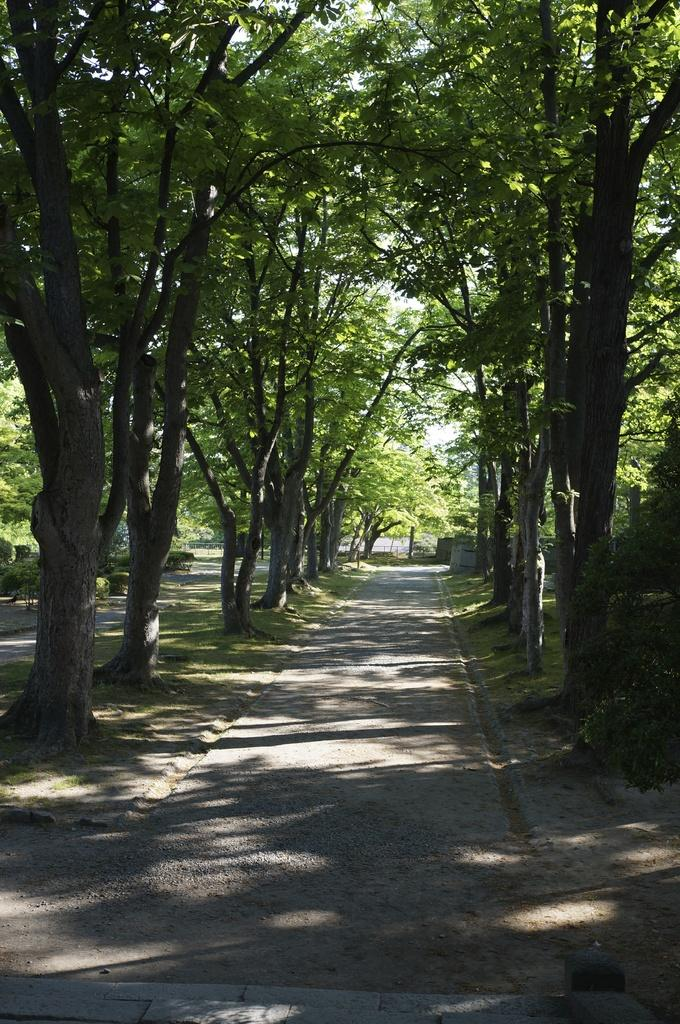What type of vegetation can be seen in the image? There are trees and plants visible in the image. What type of ground cover is present in the image? There is grass visible in the image. What part of the natural environment is visible in the image? The ground and the sky are visible in the image. Can you see any veins in the image? There are no veins visible in the image; it features natural elements such as trees, plants, grass, ground, and sky. How many attempts were made to capture the image? The number of attempts made to capture the image is not mentioned in the provided facts, and therefore cannot be determined. 